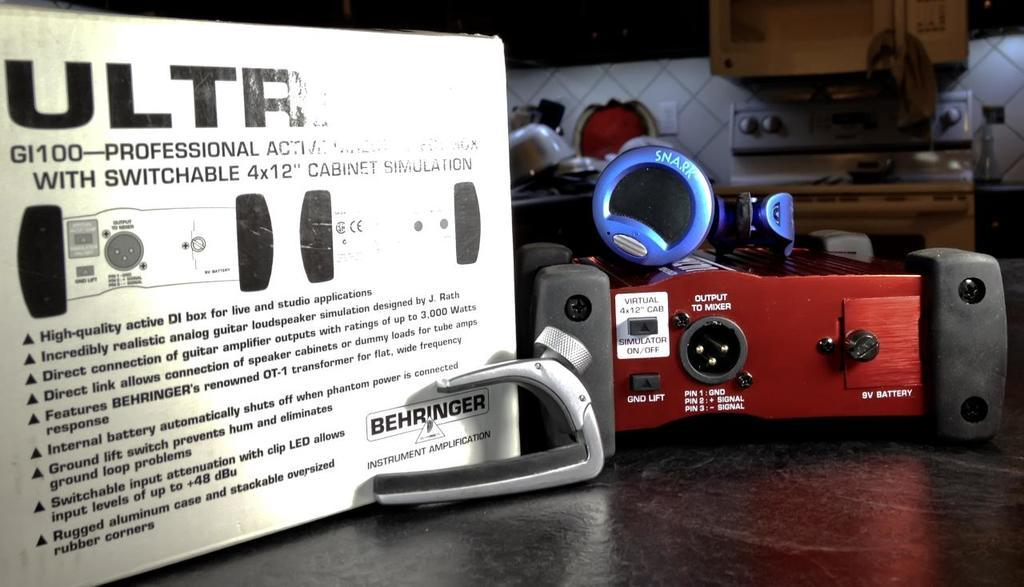<image>
Give a short and clear explanation of the subsequent image. The unit on the table has multiple plug ins including a 9V battery plug. 